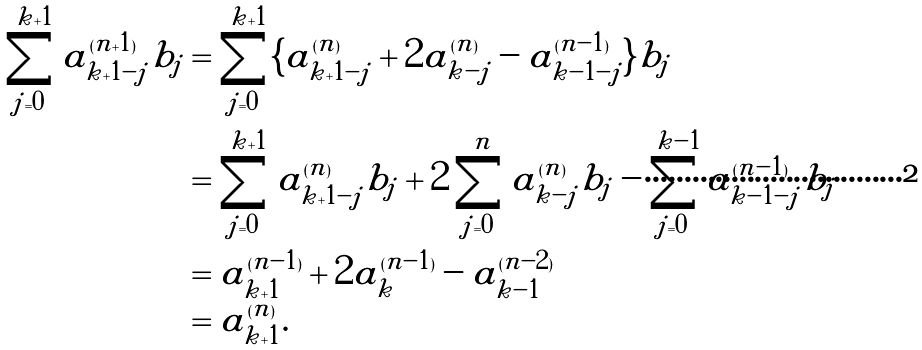<formula> <loc_0><loc_0><loc_500><loc_500>\sum _ { j = 0 } ^ { k + 1 } a _ { k + 1 - j } ^ { ( n + 1 ) } b _ { j } & = \sum _ { j = 0 } ^ { k + 1 } \{ a _ { k + 1 - j } ^ { ( n ) } + 2 a _ { k - j } ^ { ( n ) } - a _ { k - 1 - j } ^ { ( n - 1 ) } \} b _ { j } \\ & = \sum _ { j = 0 } ^ { k + 1 } a _ { k + 1 - j } ^ { ( n ) } b _ { j } + 2 \sum _ { j = 0 } ^ { n } a _ { k - j } ^ { ( n ) } b _ { j } - \sum _ { j = 0 } ^ { k - 1 } a _ { k - 1 - j } ^ { ( n - 1 ) } b _ { j } \\ & = a _ { k + 1 } ^ { ( n - 1 ) } + 2 a _ { k } ^ { ( n - 1 ) } - a _ { k - 1 } ^ { ( n - 2 ) } \\ & = a _ { k + 1 } ^ { ( n ) } .</formula> 